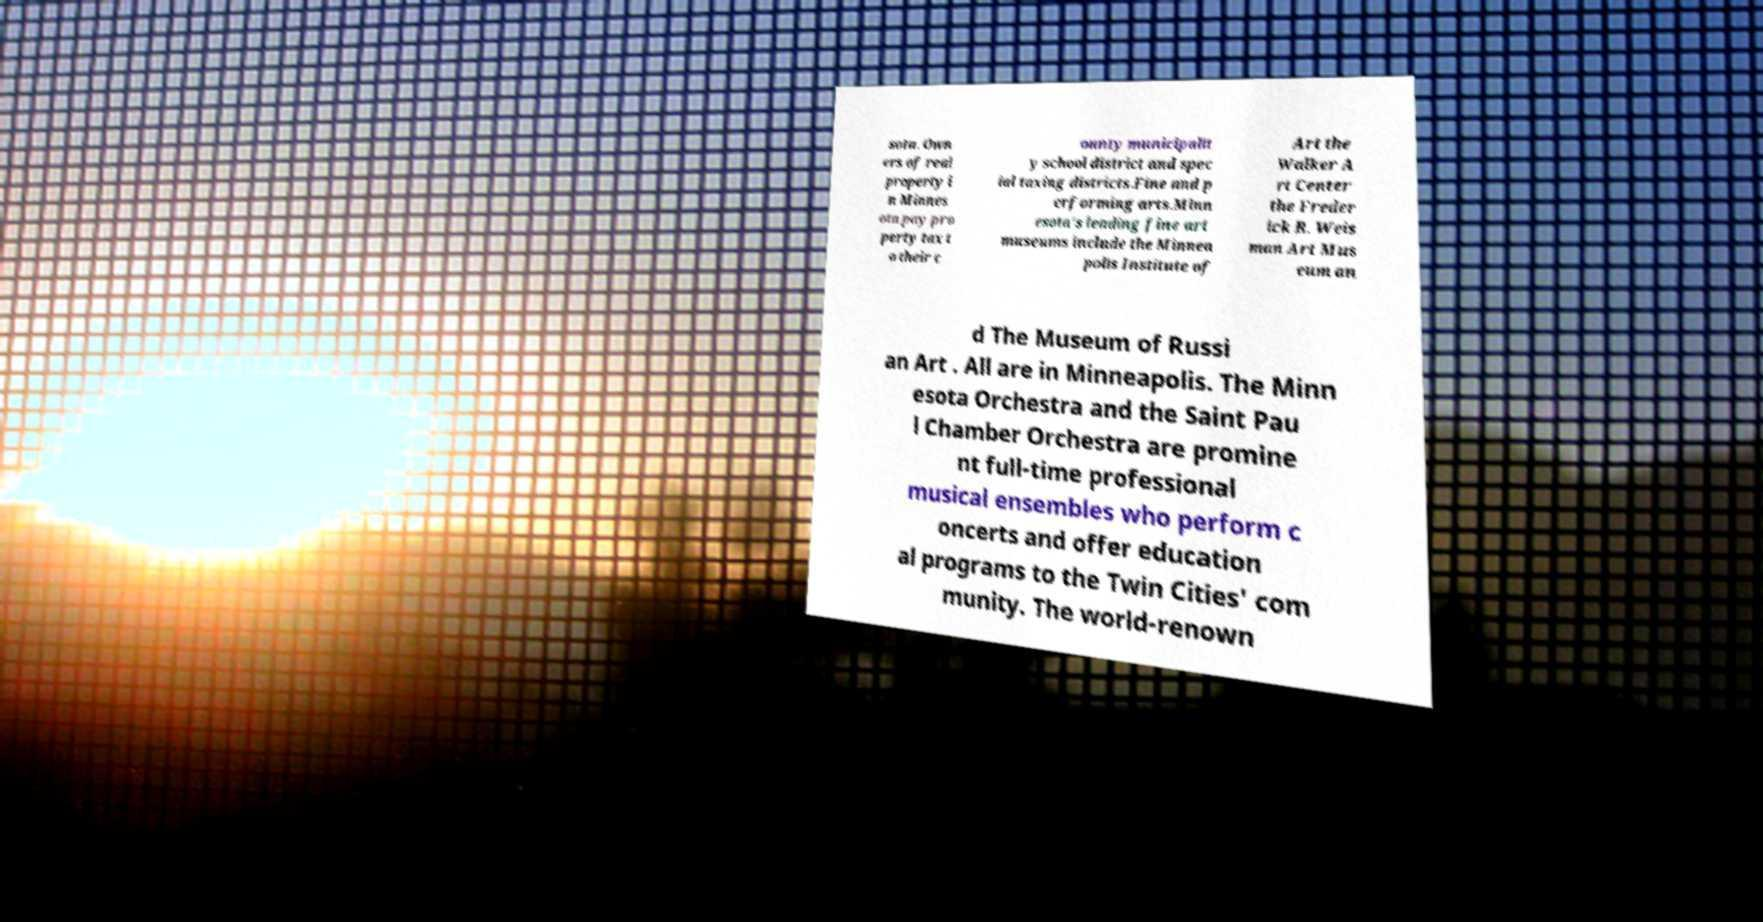Please identify and transcribe the text found in this image. sota. Own ers of real property i n Minnes ota pay pro perty tax t o their c ounty municipalit y school district and spec ial taxing districts.Fine and p erforming arts.Minn esota's leading fine art museums include the Minnea polis Institute of Art the Walker A rt Center the Freder ick R. Weis man Art Mus eum an d The Museum of Russi an Art . All are in Minneapolis. The Minn esota Orchestra and the Saint Pau l Chamber Orchestra are promine nt full-time professional musical ensembles who perform c oncerts and offer education al programs to the Twin Cities' com munity. The world-renown 